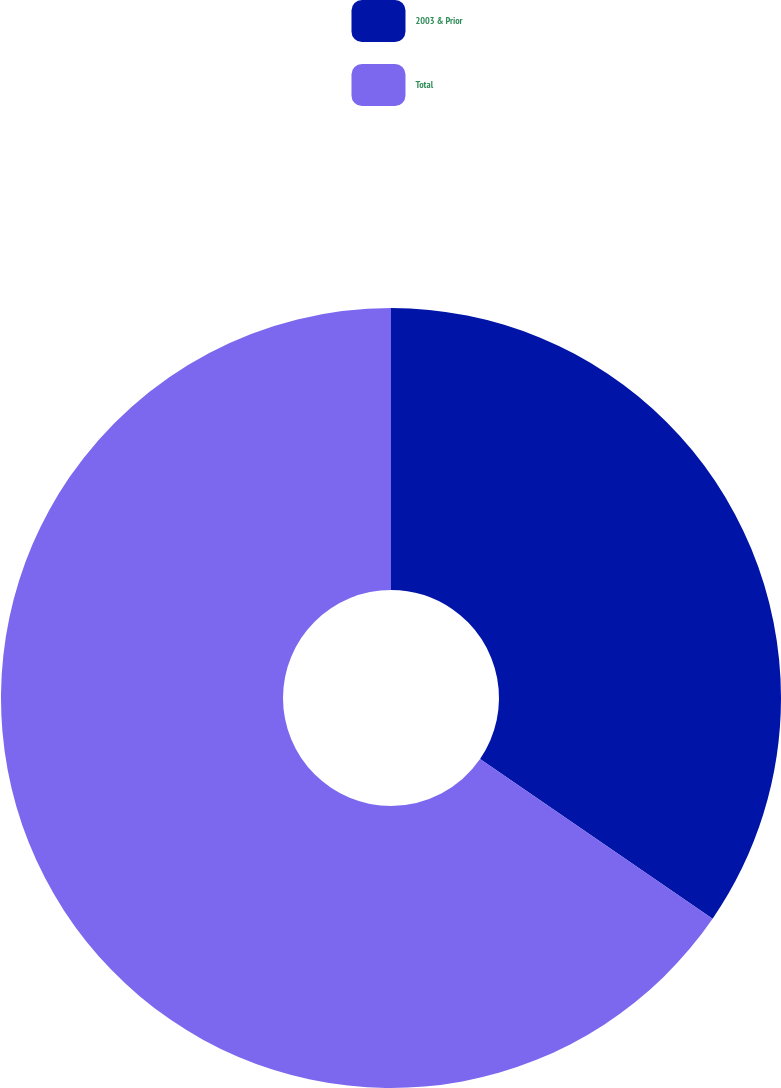<chart> <loc_0><loc_0><loc_500><loc_500><pie_chart><fcel>2003 & Prior<fcel>Total<nl><fcel>34.57%<fcel>65.43%<nl></chart> 